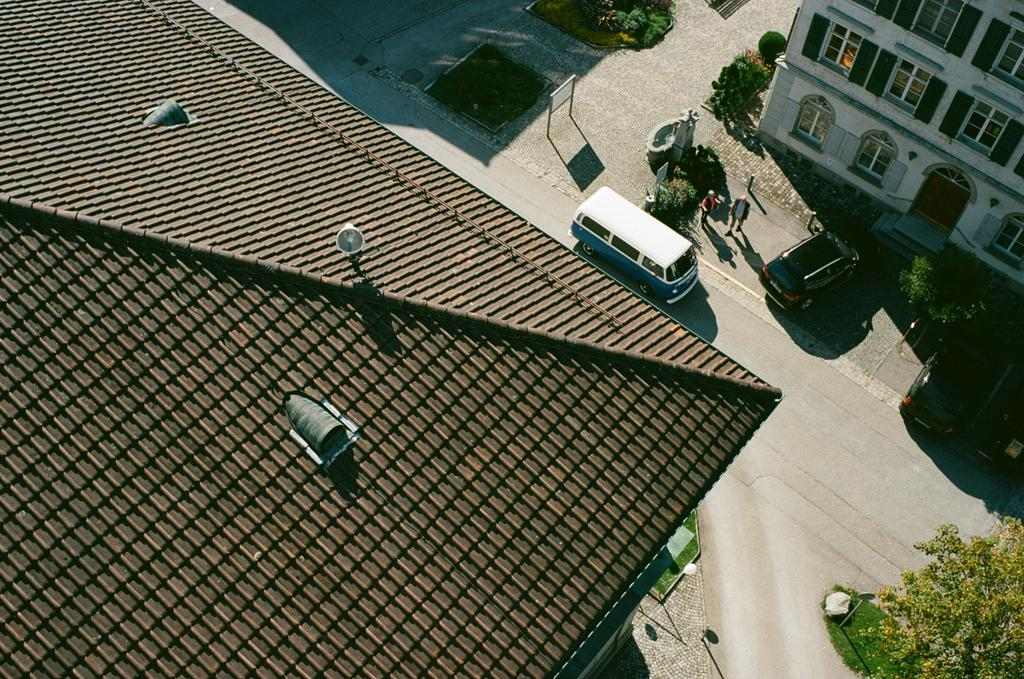What part of a building can be seen in the image? The roof of a building is visible in the image. What else can be seen in the image besides the roof? There are other buildings, windows, a door, trees, grass, plants, poles, and vehicles visible in the image. Can you describe the board in the image? There is a board in the image, but its specific details are not mentioned in the provided facts. What type of vegetation is present in the image? Trees, grass, and plants are present in the image. How many icicles can be seen hanging from the roof in the image? There is no mention of icicles in the provided facts, so it cannot be determined from the image. 